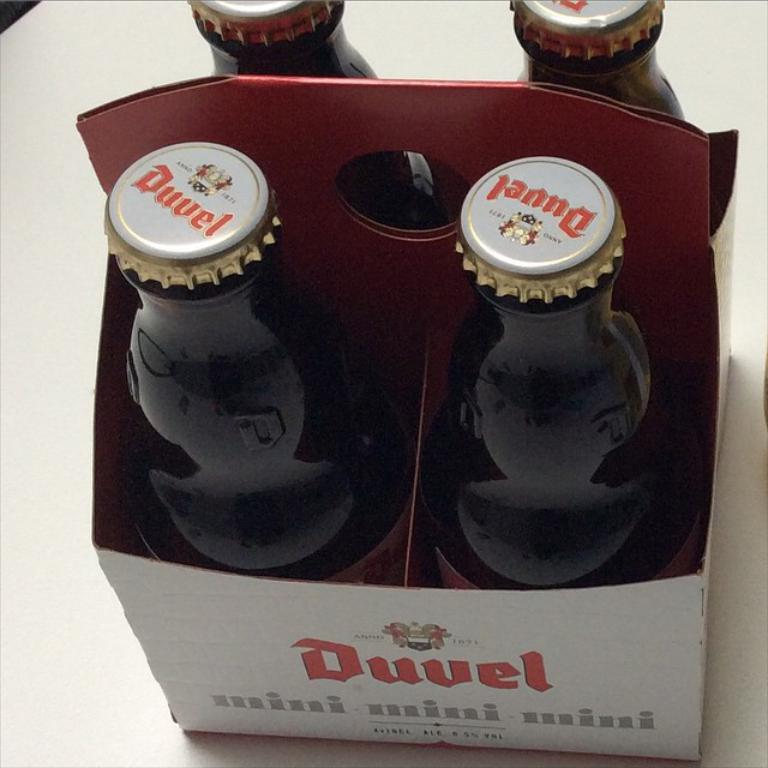<image>
Give a short and clear explanation of the subsequent image. A pack of Duvel beers features four bottles in the box. 